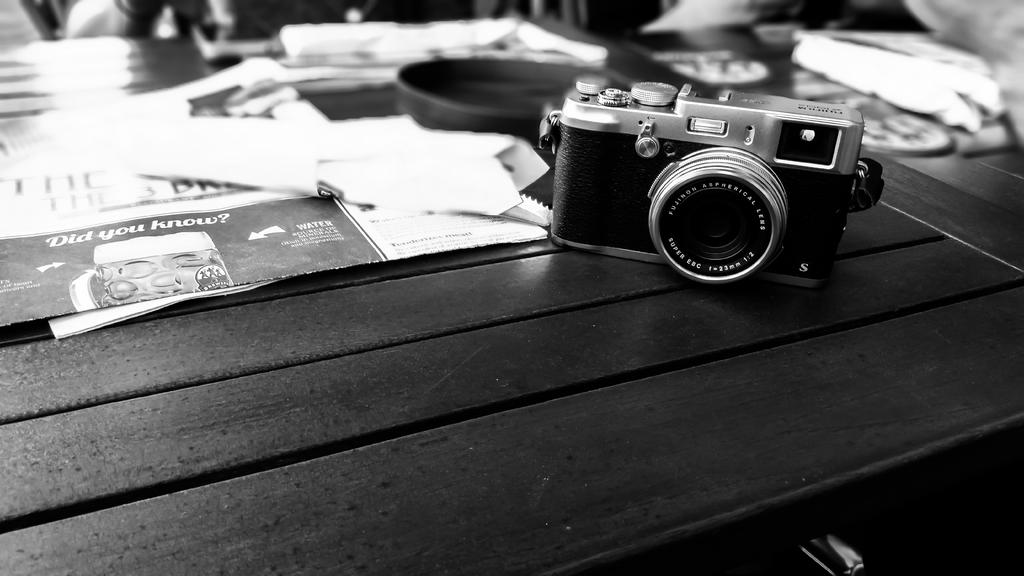What object is located at the top side of the image? There is a camera in the image, and it is at the top side. Where is the camera placed in the image? The camera is on a table in the image. What else can be seen on the table besides the camera? There are papers on the table in the image. What activity are the sisters participating in inside the cave in the image? There is no mention of a cave or sisters in the image; it only features a camera on a table with papers. 